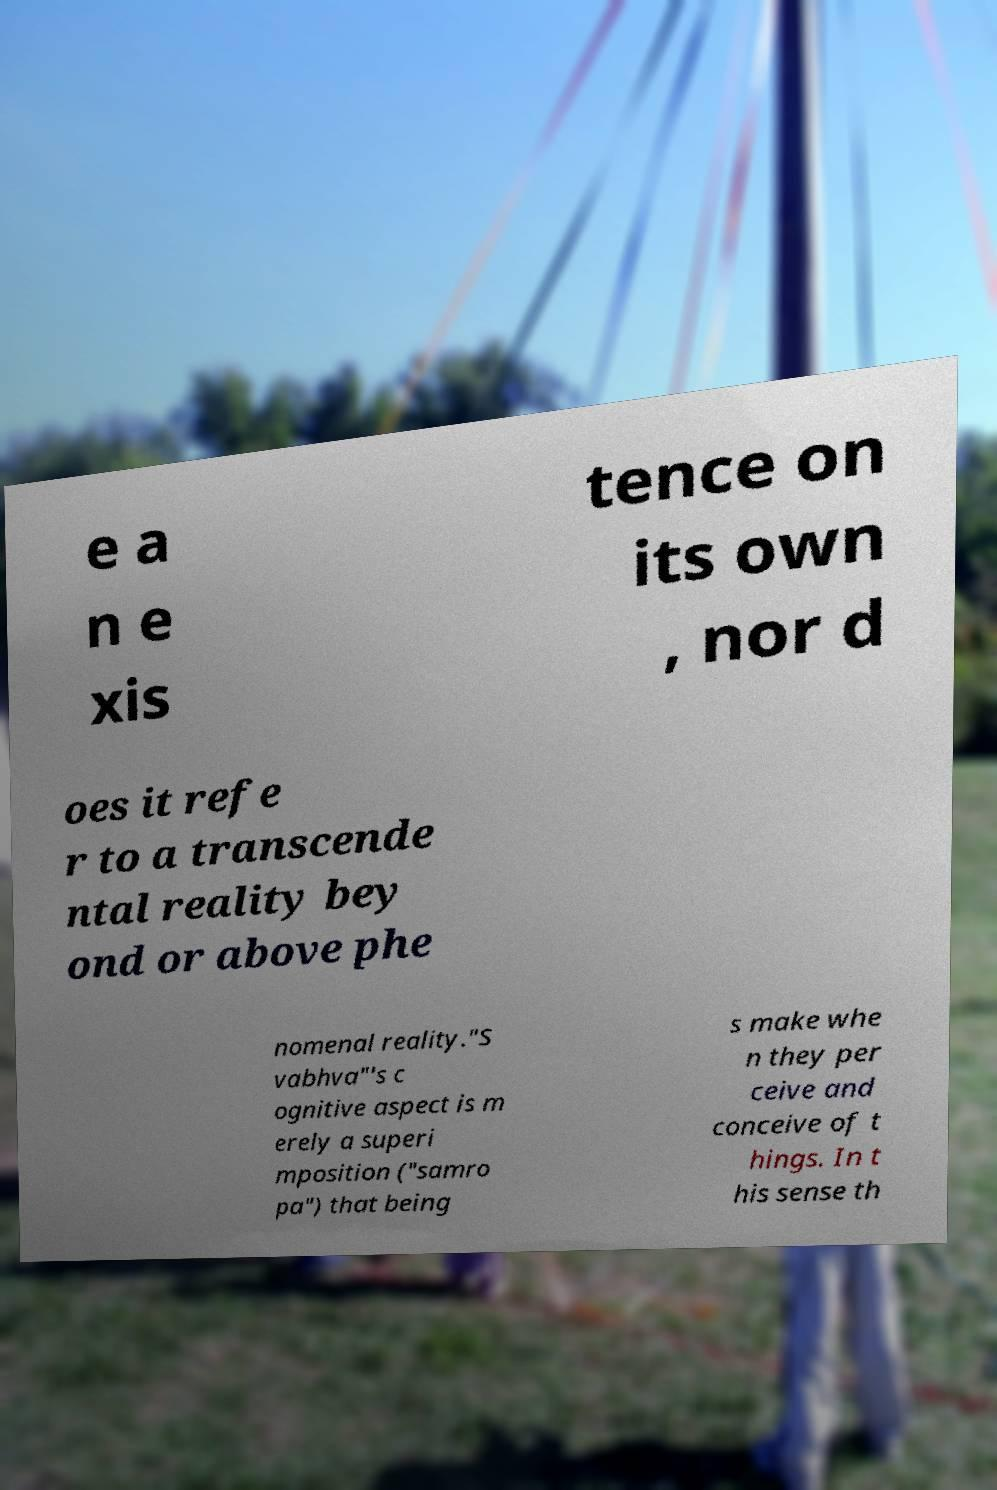Please read and relay the text visible in this image. What does it say? e a n e xis tence on its own , nor d oes it refe r to a transcende ntal reality bey ond or above phe nomenal reality."S vabhva"'s c ognitive aspect is m erely a superi mposition ("samro pa") that being s make whe n they per ceive and conceive of t hings. In t his sense th 